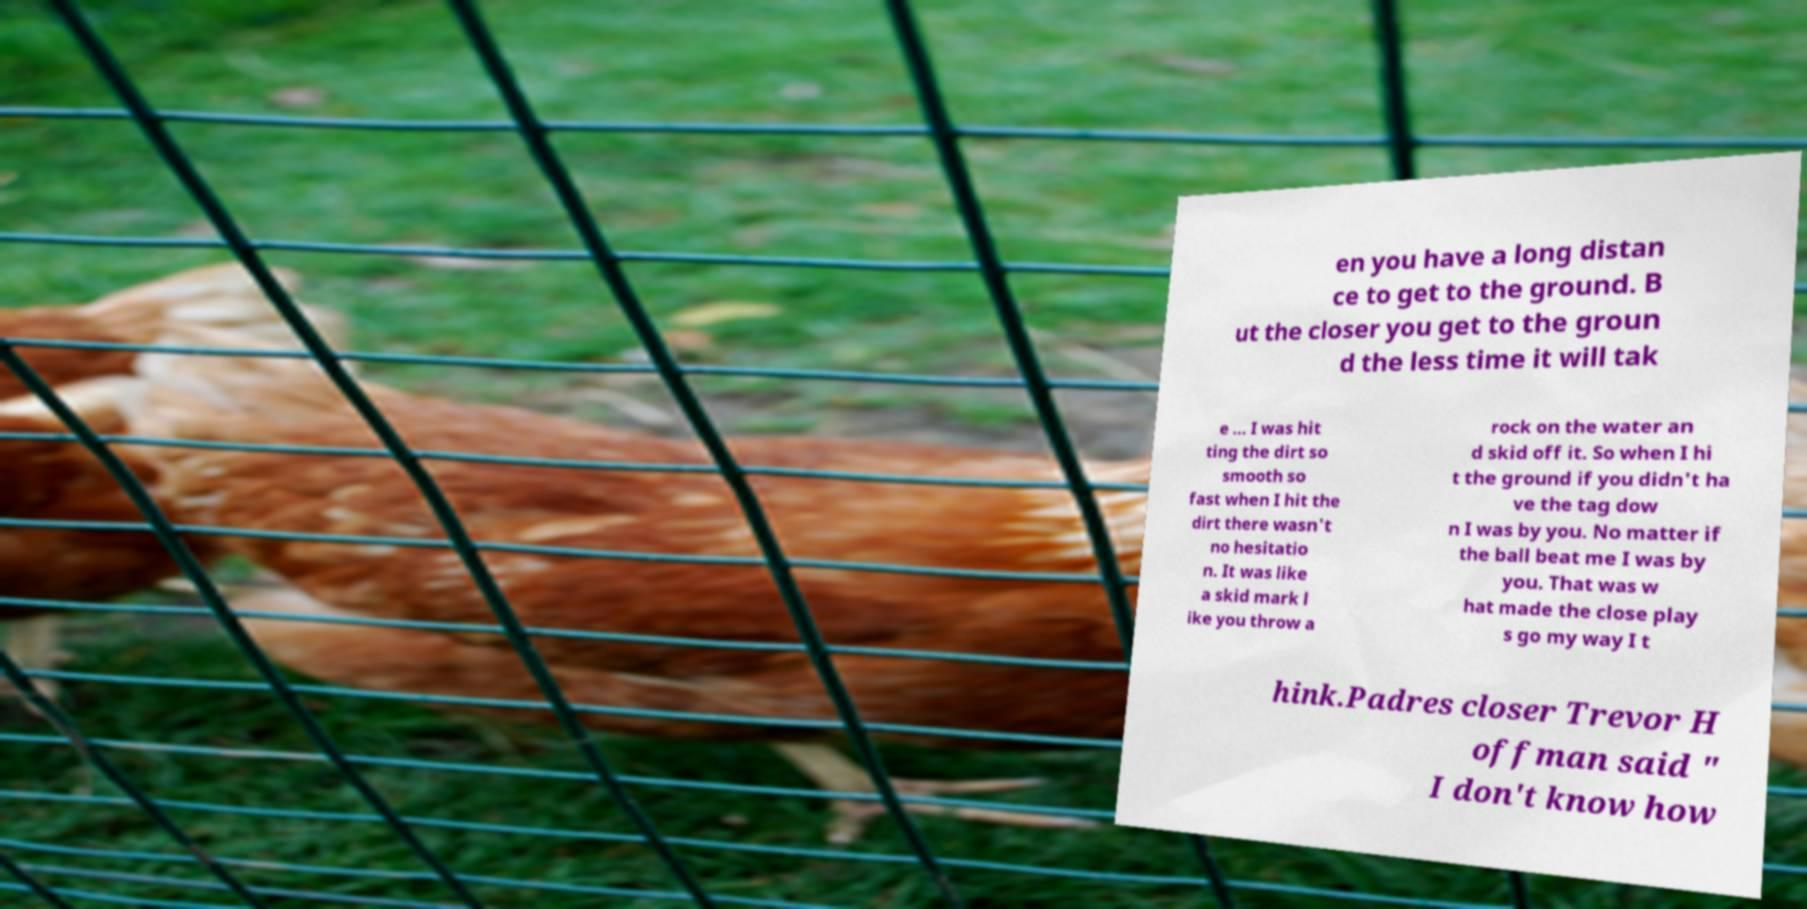Please identify and transcribe the text found in this image. en you have a long distan ce to get to the ground. B ut the closer you get to the groun d the less time it will tak e ... I was hit ting the dirt so smooth so fast when I hit the dirt there wasn't no hesitatio n. It was like a skid mark l ike you throw a rock on the water an d skid off it. So when I hi t the ground if you didn't ha ve the tag dow n I was by you. No matter if the ball beat me I was by you. That was w hat made the close play s go my way I t hink.Padres closer Trevor H offman said " I don't know how 